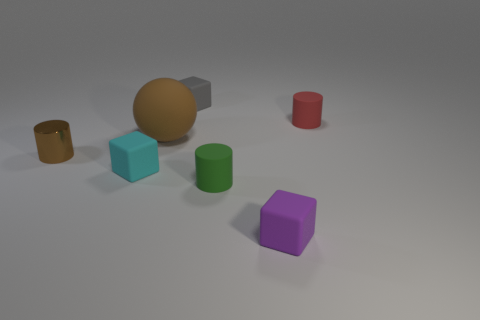What shape is the object that is in front of the small rubber cylinder in front of the brown metallic cylinder? cube 